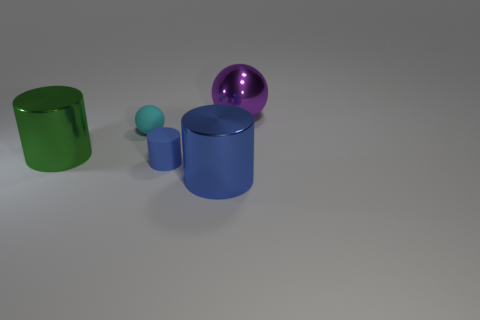What is the size of the other cylinder that is the same color as the tiny cylinder?
Provide a succinct answer. Large. Are there any shiny objects of the same color as the matte cylinder?
Provide a succinct answer. Yes. Do the large cylinder right of the rubber ball and the small rubber cylinder have the same color?
Your answer should be very brief. Yes. How many other objects are the same material as the purple thing?
Give a very brief answer. 2. What shape is the object that is the same color as the small cylinder?
Keep it short and to the point. Cylinder. What shape is the green object that is the same size as the purple metallic object?
Keep it short and to the point. Cylinder. There is a thing that is the same color as the matte cylinder; what is it made of?
Give a very brief answer. Metal. There is a big shiny sphere; are there any purple metal balls left of it?
Offer a very short reply. No. Is there a big green thing that has the same shape as the tiny cyan rubber thing?
Your answer should be compact. No. There is a blue object that is on the left side of the large blue metal object; is its shape the same as the large object behind the cyan sphere?
Ensure brevity in your answer.  No. 